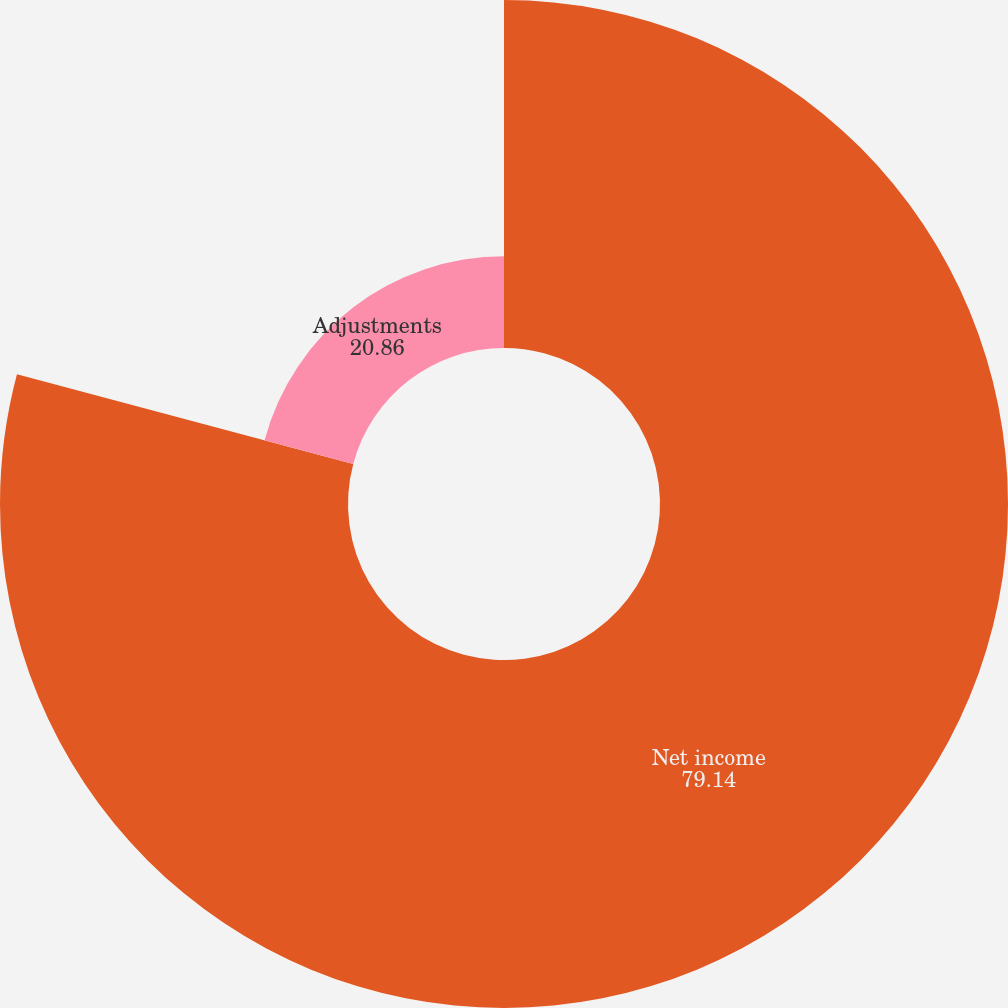Convert chart. <chart><loc_0><loc_0><loc_500><loc_500><pie_chart><fcel>Net income<fcel>Adjustments<nl><fcel>79.14%<fcel>20.86%<nl></chart> 